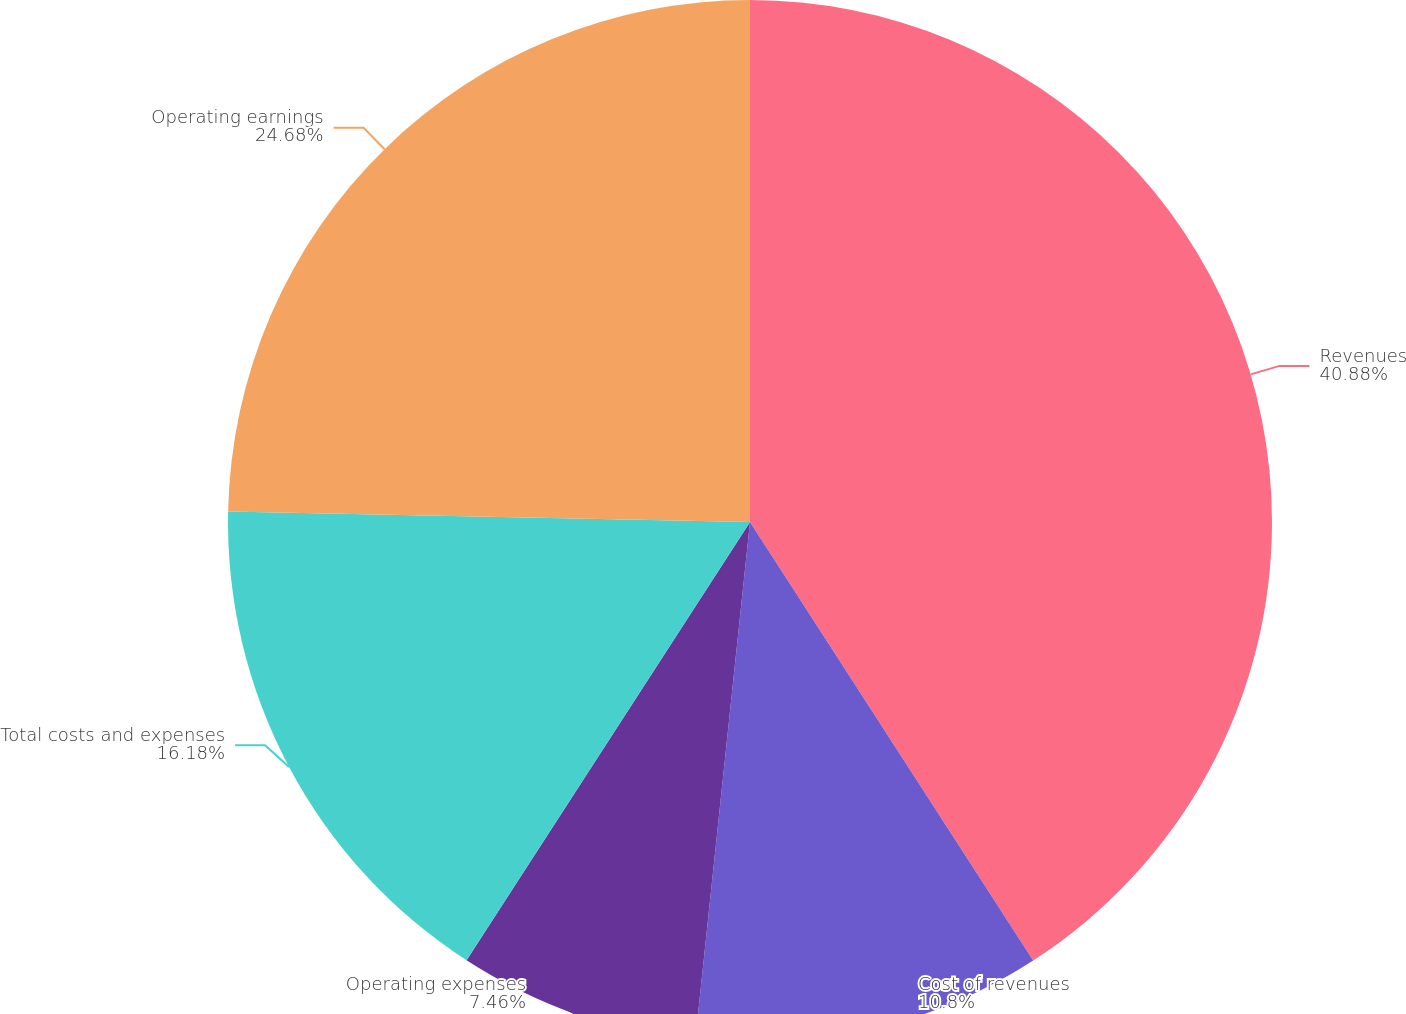Convert chart. <chart><loc_0><loc_0><loc_500><loc_500><pie_chart><fcel>Revenues<fcel>Cost of revenues<fcel>Operating expenses<fcel>Total costs and expenses<fcel>Operating earnings<nl><fcel>40.87%<fcel>10.8%<fcel>7.46%<fcel>16.18%<fcel>24.68%<nl></chart> 